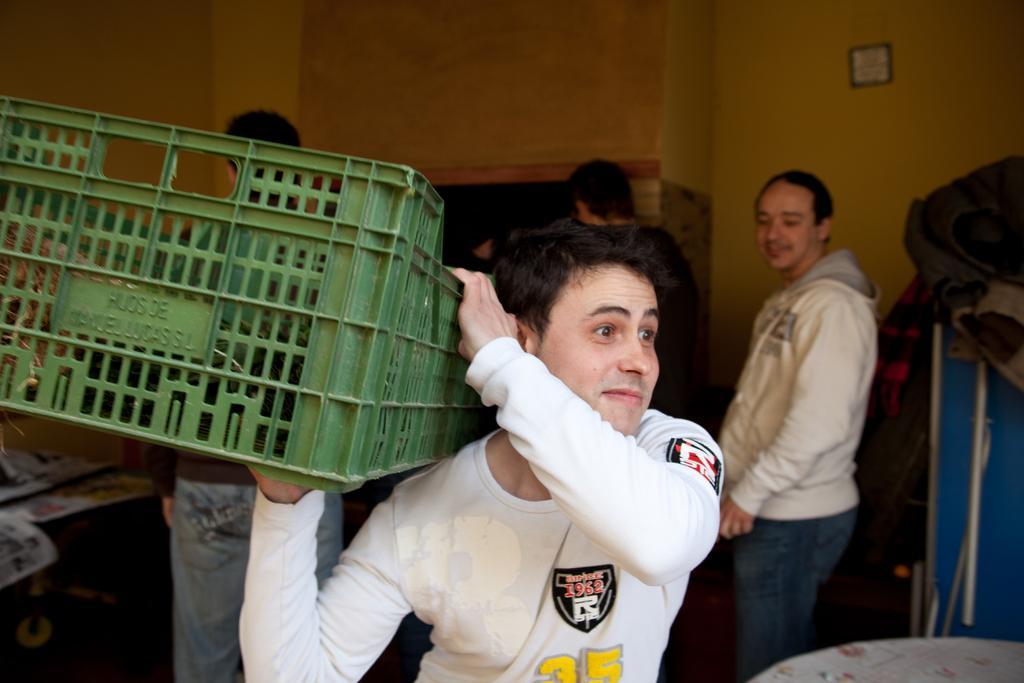Please provide a concise description of this image. In this picture we can see a man carrying a basket with his hands and smiling and at the back of him we can see some people, clothes, papers and some objects and in the background we can see an object on the wall. 